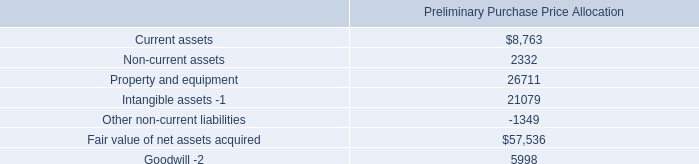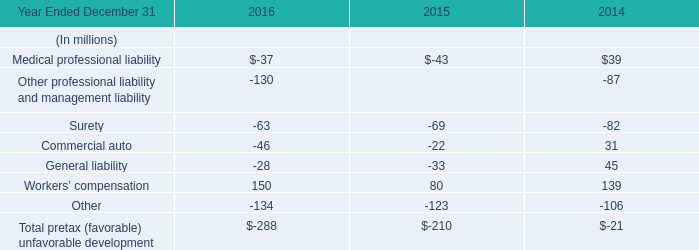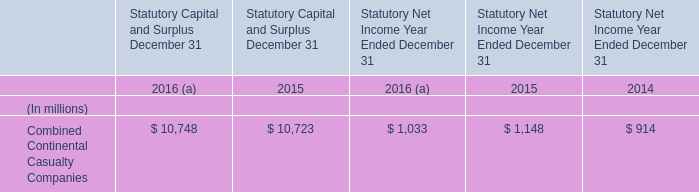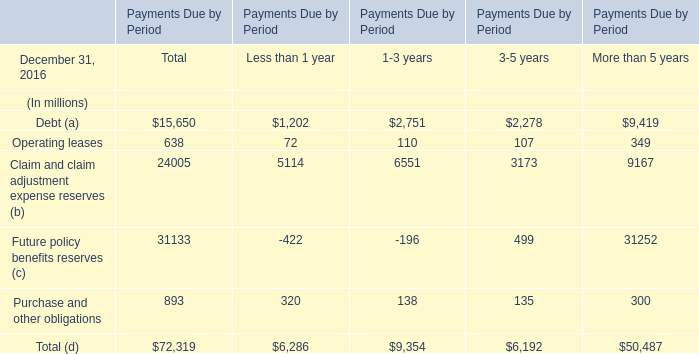what was the ratio of the customer-related intangibles to the network location intangibles included in the financial statements of american tower corporation and subsidiaries 
Computations: (75.0 / 72.7)
Answer: 1.03164. 